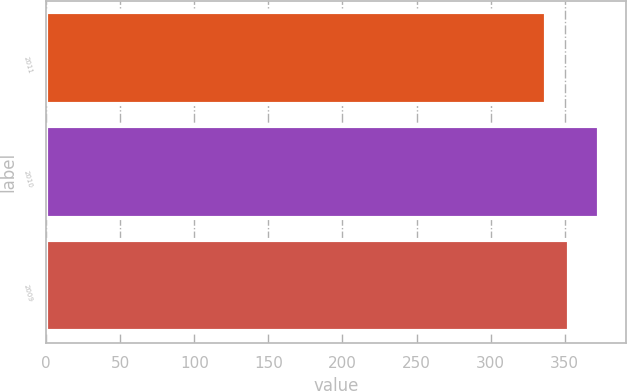<chart> <loc_0><loc_0><loc_500><loc_500><bar_chart><fcel>2011<fcel>2010<fcel>2009<nl><fcel>337.2<fcel>372.9<fcel>353.1<nl></chart> 